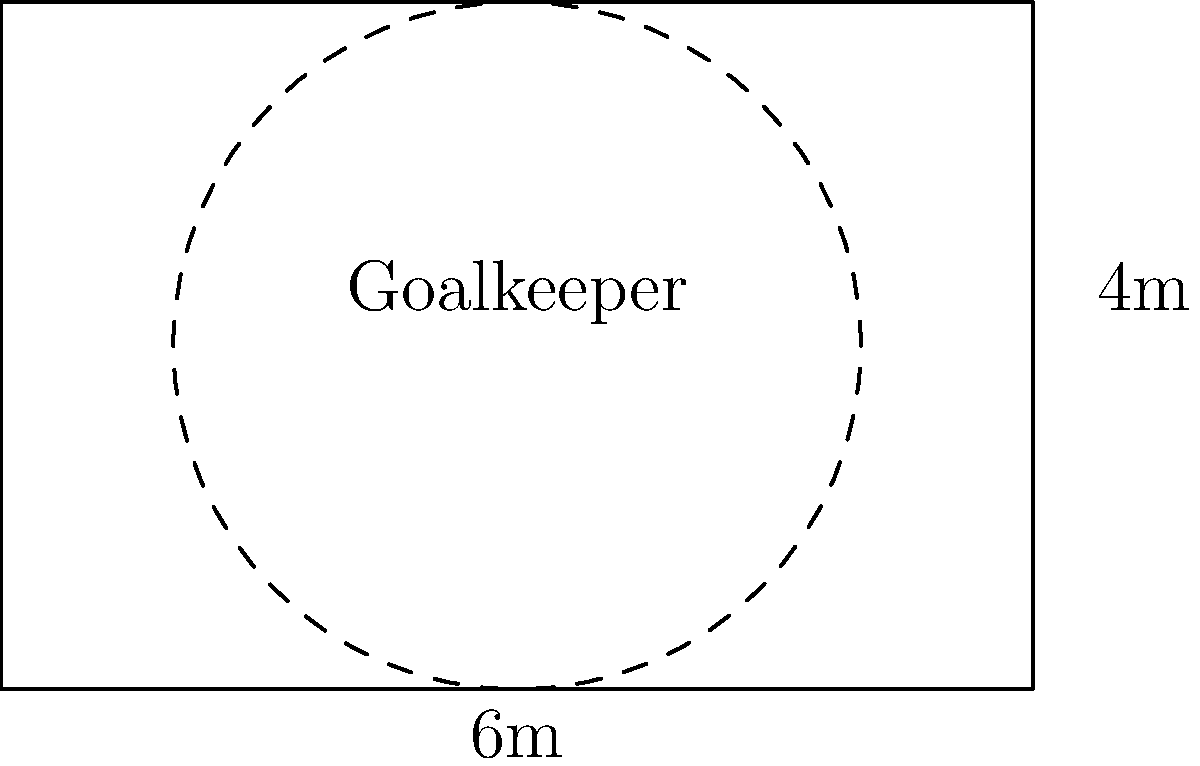A goalkeeper's diving range is represented by a circle with a 2-meter radius. If the penalty area is 6 meters wide and 4 meters deep, what percentage of the penalty area is covered by the goalkeeper's diving range? To solve this problem, we need to follow these steps:

1. Calculate the area of the penalty area:
   Area of rectangle = length × width
   $A_r = 6 \text{ m} \times 4 \text{ m} = 24 \text{ m}^2$

2. Calculate the area of the goalkeeper's diving range:
   Area of circle = $\pi r^2$
   $A_c = \pi \times (2 \text{ m})^2 = 4\pi \text{ m}^2$

3. Calculate the percentage of the penalty area covered:
   Percentage = $\frac{\text{Area of circle}}{\text{Area of rectangle}} \times 100\%$
   $= \frac{4\pi \text{ m}^2}{24 \text{ m}^2} \times 100\%$
   $= \frac{\pi}{6} \times 100\%$
   $\approx 52.36\%$

Therefore, the goalkeeper's diving range covers approximately 52.36% of the penalty area.
Answer: 52.36% 